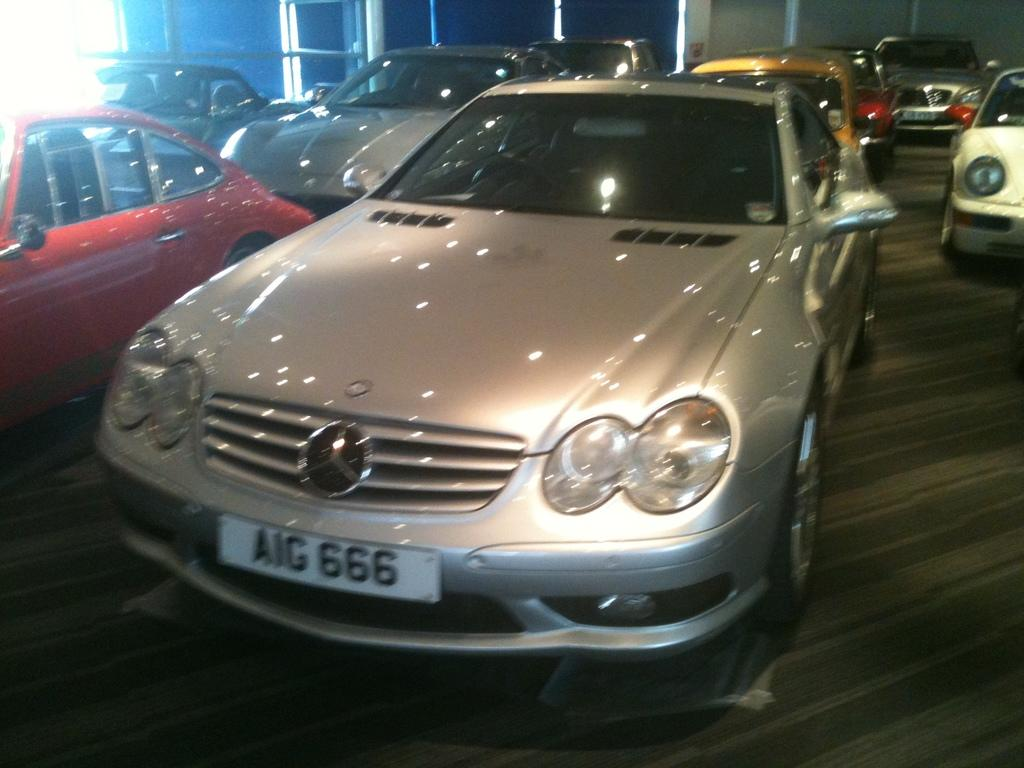What objects are on the floor in the image? There are cars on the floor in the image. What can be seen in the background of the image? There are poles and a wall in the background of the image. What type of rock is visible on the floor in the image? There is no rock visible on the floor in the image; it features cars instead. 